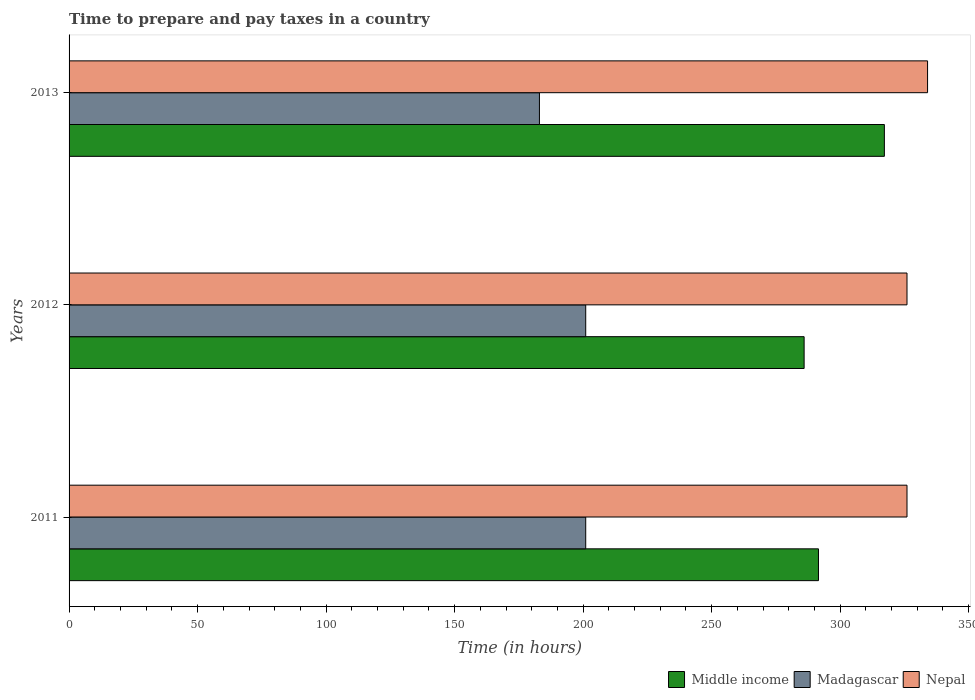How many groups of bars are there?
Offer a terse response. 3. Are the number of bars per tick equal to the number of legend labels?
Make the answer very short. Yes. What is the number of hours required to prepare and pay taxes in Middle income in 2013?
Ensure brevity in your answer.  317.19. Across all years, what is the maximum number of hours required to prepare and pay taxes in Madagascar?
Offer a very short reply. 201. Across all years, what is the minimum number of hours required to prepare and pay taxes in Middle income?
Provide a succinct answer. 285.97. What is the total number of hours required to prepare and pay taxes in Madagascar in the graph?
Your response must be concise. 585. What is the difference between the number of hours required to prepare and pay taxes in Middle income in 2012 and that in 2013?
Keep it short and to the point. -31.22. What is the difference between the number of hours required to prepare and pay taxes in Nepal in 2011 and the number of hours required to prepare and pay taxes in Middle income in 2012?
Make the answer very short. 40.03. What is the average number of hours required to prepare and pay taxes in Madagascar per year?
Provide a short and direct response. 195. In the year 2013, what is the difference between the number of hours required to prepare and pay taxes in Middle income and number of hours required to prepare and pay taxes in Madagascar?
Ensure brevity in your answer.  134.19. What is the ratio of the number of hours required to prepare and pay taxes in Middle income in 2012 to that in 2013?
Give a very brief answer. 0.9. What is the difference between the highest and the second highest number of hours required to prepare and pay taxes in Madagascar?
Provide a succinct answer. 0. What is the difference between the highest and the lowest number of hours required to prepare and pay taxes in Middle income?
Give a very brief answer. 31.22. In how many years, is the number of hours required to prepare and pay taxes in Nepal greater than the average number of hours required to prepare and pay taxes in Nepal taken over all years?
Ensure brevity in your answer.  1. What does the 1st bar from the top in 2011 represents?
Give a very brief answer. Nepal. What does the 3rd bar from the bottom in 2011 represents?
Provide a succinct answer. Nepal. Is it the case that in every year, the sum of the number of hours required to prepare and pay taxes in Madagascar and number of hours required to prepare and pay taxes in Middle income is greater than the number of hours required to prepare and pay taxes in Nepal?
Offer a terse response. Yes. How many bars are there?
Ensure brevity in your answer.  9. Are all the bars in the graph horizontal?
Ensure brevity in your answer.  Yes. How many years are there in the graph?
Your answer should be very brief. 3. Are the values on the major ticks of X-axis written in scientific E-notation?
Offer a very short reply. No. How are the legend labels stacked?
Your answer should be very brief. Horizontal. What is the title of the graph?
Offer a very short reply. Time to prepare and pay taxes in a country. What is the label or title of the X-axis?
Provide a succinct answer. Time (in hours). What is the label or title of the Y-axis?
Offer a very short reply. Years. What is the Time (in hours) in Middle income in 2011?
Give a very brief answer. 291.56. What is the Time (in hours) of Madagascar in 2011?
Offer a very short reply. 201. What is the Time (in hours) in Nepal in 2011?
Keep it short and to the point. 326. What is the Time (in hours) in Middle income in 2012?
Provide a short and direct response. 285.97. What is the Time (in hours) of Madagascar in 2012?
Your answer should be very brief. 201. What is the Time (in hours) of Nepal in 2012?
Your response must be concise. 326. What is the Time (in hours) of Middle income in 2013?
Offer a very short reply. 317.19. What is the Time (in hours) in Madagascar in 2013?
Provide a succinct answer. 183. What is the Time (in hours) in Nepal in 2013?
Ensure brevity in your answer.  334. Across all years, what is the maximum Time (in hours) of Middle income?
Ensure brevity in your answer.  317.19. Across all years, what is the maximum Time (in hours) in Madagascar?
Ensure brevity in your answer.  201. Across all years, what is the maximum Time (in hours) in Nepal?
Ensure brevity in your answer.  334. Across all years, what is the minimum Time (in hours) of Middle income?
Offer a terse response. 285.97. Across all years, what is the minimum Time (in hours) of Madagascar?
Keep it short and to the point. 183. Across all years, what is the minimum Time (in hours) in Nepal?
Give a very brief answer. 326. What is the total Time (in hours) in Middle income in the graph?
Offer a terse response. 894.72. What is the total Time (in hours) in Madagascar in the graph?
Provide a succinct answer. 585. What is the total Time (in hours) of Nepal in the graph?
Keep it short and to the point. 986. What is the difference between the Time (in hours) in Middle income in 2011 and that in 2012?
Offer a very short reply. 5.58. What is the difference between the Time (in hours) in Nepal in 2011 and that in 2012?
Make the answer very short. 0. What is the difference between the Time (in hours) in Middle income in 2011 and that in 2013?
Ensure brevity in your answer.  -25.64. What is the difference between the Time (in hours) of Madagascar in 2011 and that in 2013?
Give a very brief answer. 18. What is the difference between the Time (in hours) in Middle income in 2012 and that in 2013?
Keep it short and to the point. -31.22. What is the difference between the Time (in hours) in Madagascar in 2012 and that in 2013?
Provide a succinct answer. 18. What is the difference between the Time (in hours) of Middle income in 2011 and the Time (in hours) of Madagascar in 2012?
Make the answer very short. 90.56. What is the difference between the Time (in hours) in Middle income in 2011 and the Time (in hours) in Nepal in 2012?
Make the answer very short. -34.44. What is the difference between the Time (in hours) of Madagascar in 2011 and the Time (in hours) of Nepal in 2012?
Ensure brevity in your answer.  -125. What is the difference between the Time (in hours) in Middle income in 2011 and the Time (in hours) in Madagascar in 2013?
Your answer should be compact. 108.56. What is the difference between the Time (in hours) in Middle income in 2011 and the Time (in hours) in Nepal in 2013?
Offer a terse response. -42.44. What is the difference between the Time (in hours) of Madagascar in 2011 and the Time (in hours) of Nepal in 2013?
Make the answer very short. -133. What is the difference between the Time (in hours) of Middle income in 2012 and the Time (in hours) of Madagascar in 2013?
Make the answer very short. 102.97. What is the difference between the Time (in hours) in Middle income in 2012 and the Time (in hours) in Nepal in 2013?
Keep it short and to the point. -48.03. What is the difference between the Time (in hours) of Madagascar in 2012 and the Time (in hours) of Nepal in 2013?
Your answer should be compact. -133. What is the average Time (in hours) in Middle income per year?
Provide a succinct answer. 298.24. What is the average Time (in hours) of Madagascar per year?
Offer a very short reply. 195. What is the average Time (in hours) of Nepal per year?
Give a very brief answer. 328.67. In the year 2011, what is the difference between the Time (in hours) in Middle income and Time (in hours) in Madagascar?
Make the answer very short. 90.56. In the year 2011, what is the difference between the Time (in hours) in Middle income and Time (in hours) in Nepal?
Offer a terse response. -34.44. In the year 2011, what is the difference between the Time (in hours) of Madagascar and Time (in hours) of Nepal?
Your answer should be very brief. -125. In the year 2012, what is the difference between the Time (in hours) in Middle income and Time (in hours) in Madagascar?
Your answer should be compact. 84.97. In the year 2012, what is the difference between the Time (in hours) in Middle income and Time (in hours) in Nepal?
Provide a short and direct response. -40.03. In the year 2012, what is the difference between the Time (in hours) in Madagascar and Time (in hours) in Nepal?
Give a very brief answer. -125. In the year 2013, what is the difference between the Time (in hours) of Middle income and Time (in hours) of Madagascar?
Offer a terse response. 134.19. In the year 2013, what is the difference between the Time (in hours) of Middle income and Time (in hours) of Nepal?
Offer a terse response. -16.81. In the year 2013, what is the difference between the Time (in hours) of Madagascar and Time (in hours) of Nepal?
Make the answer very short. -151. What is the ratio of the Time (in hours) in Middle income in 2011 to that in 2012?
Offer a terse response. 1.02. What is the ratio of the Time (in hours) in Middle income in 2011 to that in 2013?
Your answer should be compact. 0.92. What is the ratio of the Time (in hours) in Madagascar in 2011 to that in 2013?
Your answer should be very brief. 1.1. What is the ratio of the Time (in hours) in Middle income in 2012 to that in 2013?
Provide a succinct answer. 0.9. What is the ratio of the Time (in hours) in Madagascar in 2012 to that in 2013?
Provide a short and direct response. 1.1. What is the difference between the highest and the second highest Time (in hours) in Middle income?
Your answer should be compact. 25.64. What is the difference between the highest and the second highest Time (in hours) of Madagascar?
Offer a very short reply. 0. What is the difference between the highest and the second highest Time (in hours) in Nepal?
Keep it short and to the point. 8. What is the difference between the highest and the lowest Time (in hours) in Middle income?
Your response must be concise. 31.22. What is the difference between the highest and the lowest Time (in hours) of Madagascar?
Your answer should be compact. 18. 